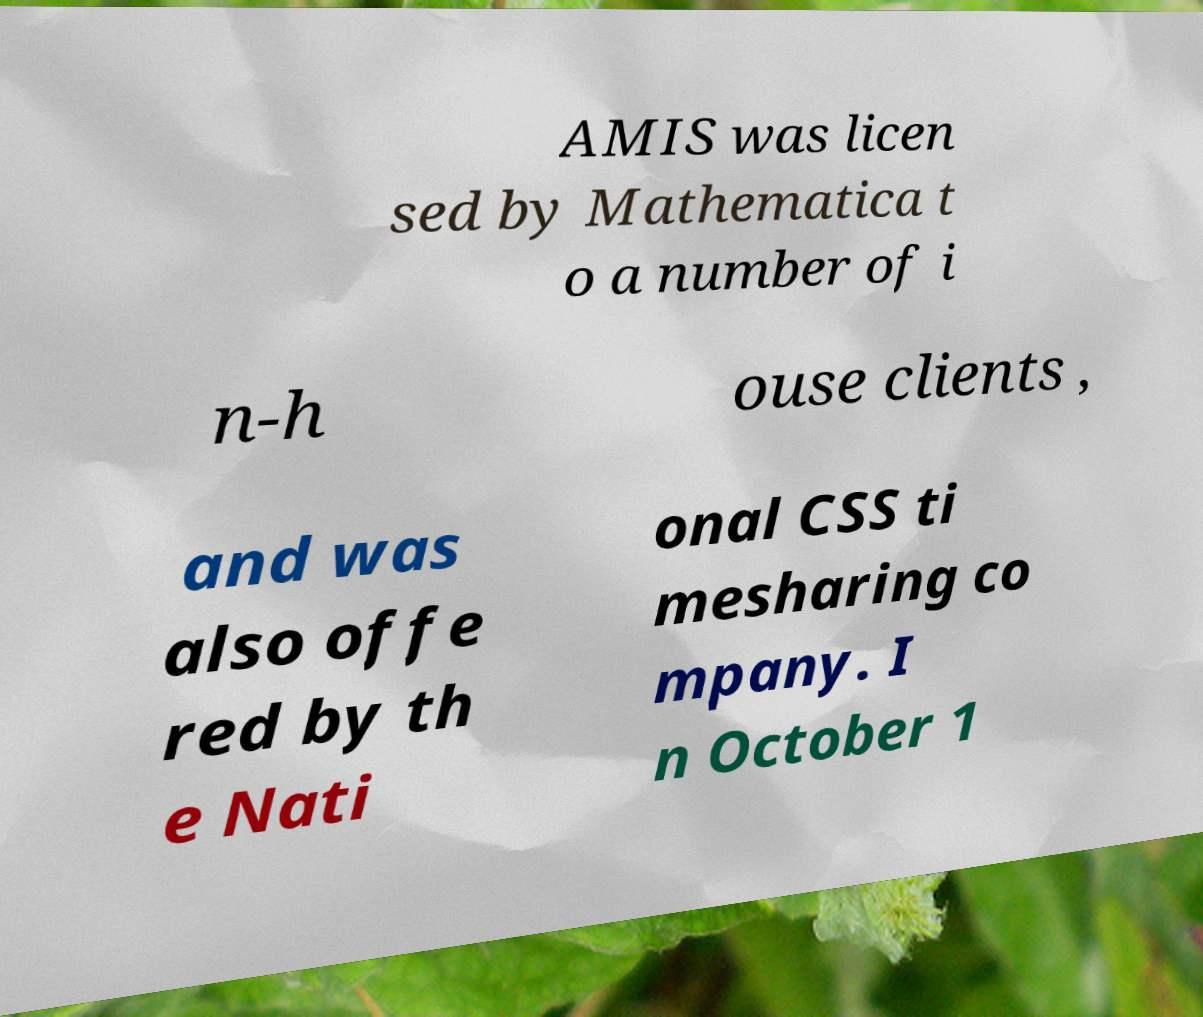What messages or text are displayed in this image? I need them in a readable, typed format. AMIS was licen sed by Mathematica t o a number of i n-h ouse clients , and was also offe red by th e Nati onal CSS ti mesharing co mpany. I n October 1 